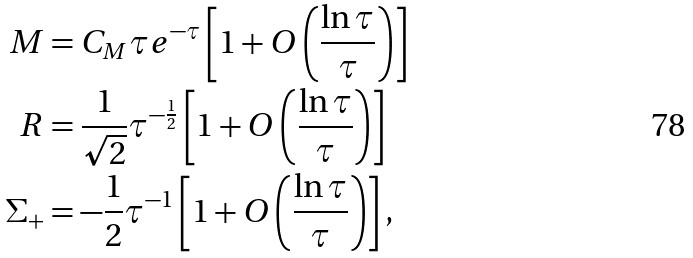Convert formula to latex. <formula><loc_0><loc_0><loc_500><loc_500>M & = C _ { M } \tau e ^ { - \tau } \left [ 1 + O \left ( \frac { \ln \tau } { \tau } \right ) \right ] \\ R & = \frac { 1 } { \sqrt { 2 } } \tau ^ { - \frac { 1 } { 2 } } \left [ 1 + O \left ( \frac { \ln \tau } { \tau } \right ) \right ] \\ \Sigma _ { + } & = - \frac { 1 } { 2 } \tau ^ { - 1 } \left [ 1 + O \left ( \frac { \ln \tau } { \tau } \right ) \right ] ,</formula> 